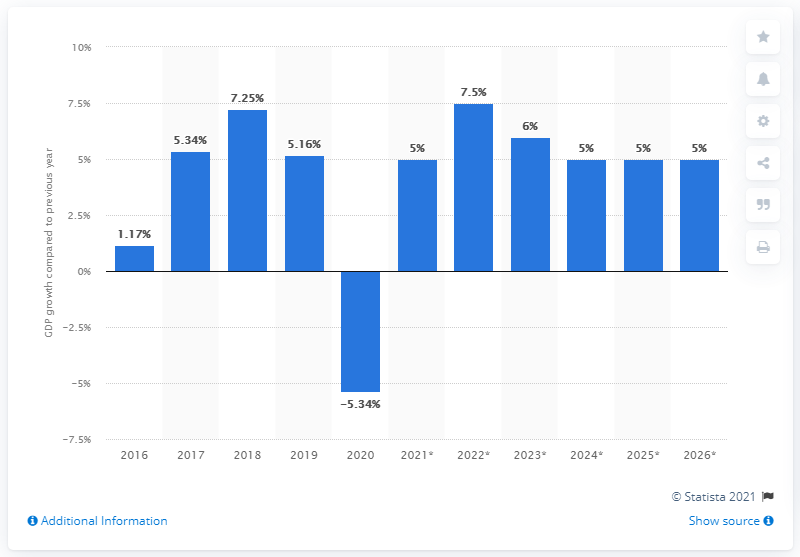Mention a couple of crucial points in this snapshot. Mongolia's gross domestic product fell by 5.34% in 2020. 